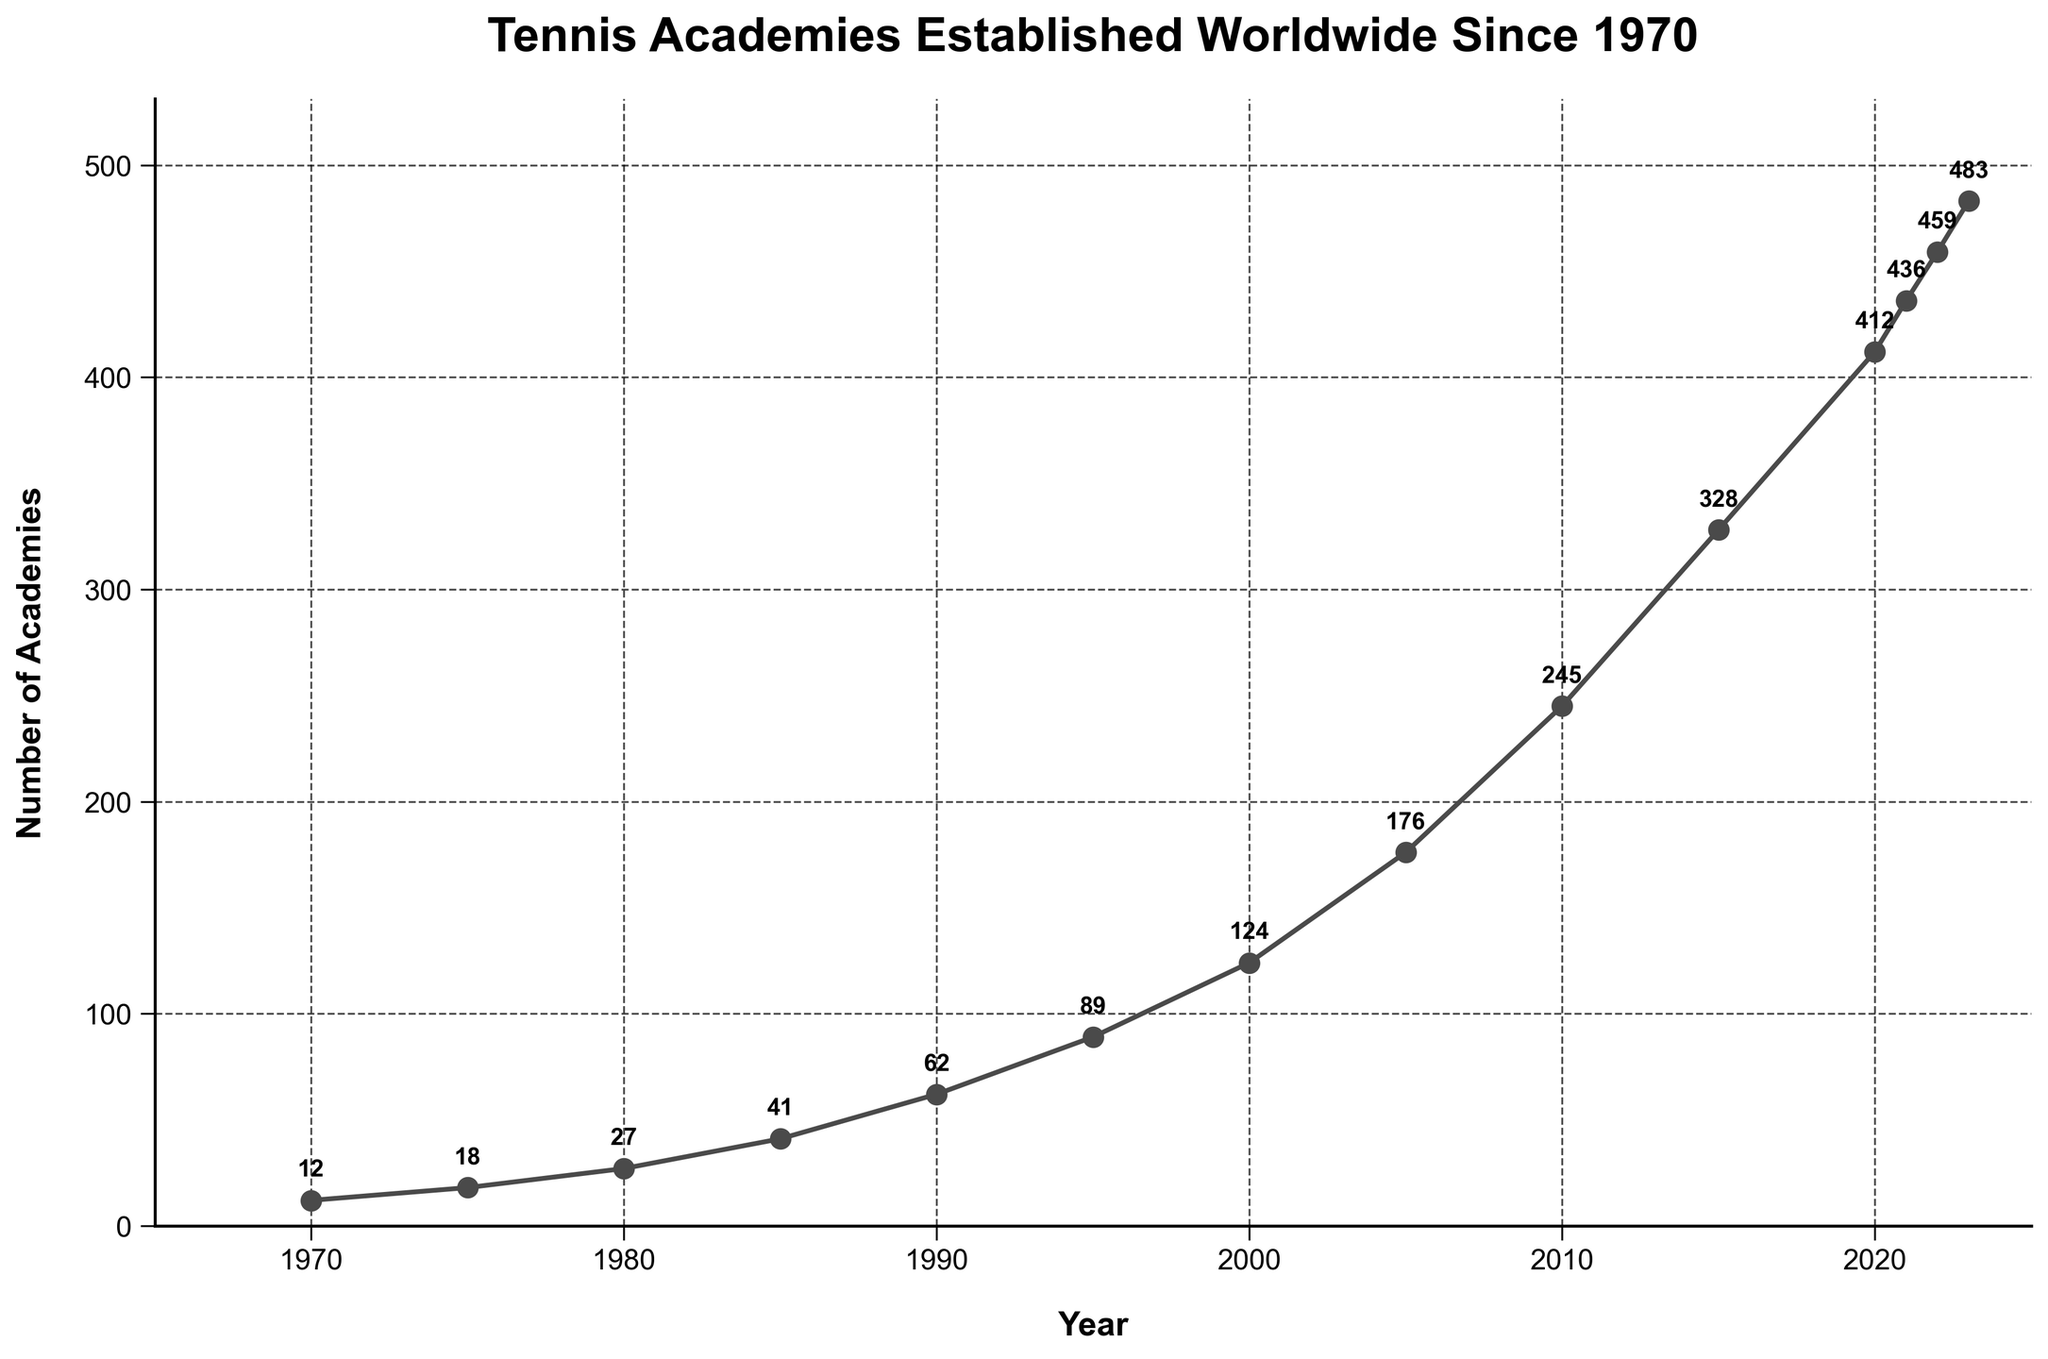When did the number of tennis academies established first exceed 100? By looking at the plotted data points, we see that the number exceeds 100 in the year 2000. Before 2000, the count is 89 in 1995, and in 2000 it jumps to 124, marking the first time it exceeds 100.
Answer: 2000 Between which years did the most significant increase in the number of tennis academies occur? To identify the most significant increase, compare the vertical distance between data points year by year. From 1970 to 2023, the biggest jump appears between 2010 (245 academies) and 2015 (328 academies), an increase of 83 academies. This is the largest single period increase.
Answer: 2010 to 2015 What is the overall trend in the number of tennis academies established between 1970 and 2023? Analyzing the line chart shows a clear upward trend from 12 academies in 1970 to 483 in 2023, indicating substantial growth in the establishment of tennis academies over the years.
Answer: Upward trend Which year had the fewest number of tennis academies established, and what was the count? By checking the plot and the data annotations, it’s evident that 1970 had the fewest with 12 academies established.
Answer: 1970, 12 academies Calculate the average number of tennis academies established every five years from 1970 to 2020. To find the average, sum the academies’ counts at each five-year interval and then divide by the number of intervals:
  (12 + 18 + 27 + 41 + 62 + 89 + 124 + 176 + 245 + 328 + 412) / 11 = 1534 / 11 ≈ 139.5.
Answer: 139.5 How does the number of tennis academies established in 2023 compare to the number in 1985? In 1985, the number of academies was 41, while in 2023, it is 483. Comparing these, 2023 had significantly more academies established than 1985.
Answer: More in 2023 Identify the year when the growth rate in the number of tennis academies appears to slow down the most. Looking closely at the slopes between data points, from 2020 (412 academies) to 2021 (436 academies) shows the smallest incremental growth compared to other periods, with only a 24-academy increase.
Answer: 2020 to 2021 What is the total increase in the number of tennis academies established from 1970 to 2023? Calculate the difference between the number of academies in 2023 and 1970: 483 (2023) - 12 (1970) = 471.
Answer: 471 Which year-to-year transition shows no significant change in the number of tennis academies established? Analyze the number of academies established each year. From 2022 (459 academies) to 2023 (483 academies), there is a good increase, so no transition year shows no significant change. The smallest change is between 2020 and 2021, but all transitions show some level of increase making it significant in their context.
Answer: None 